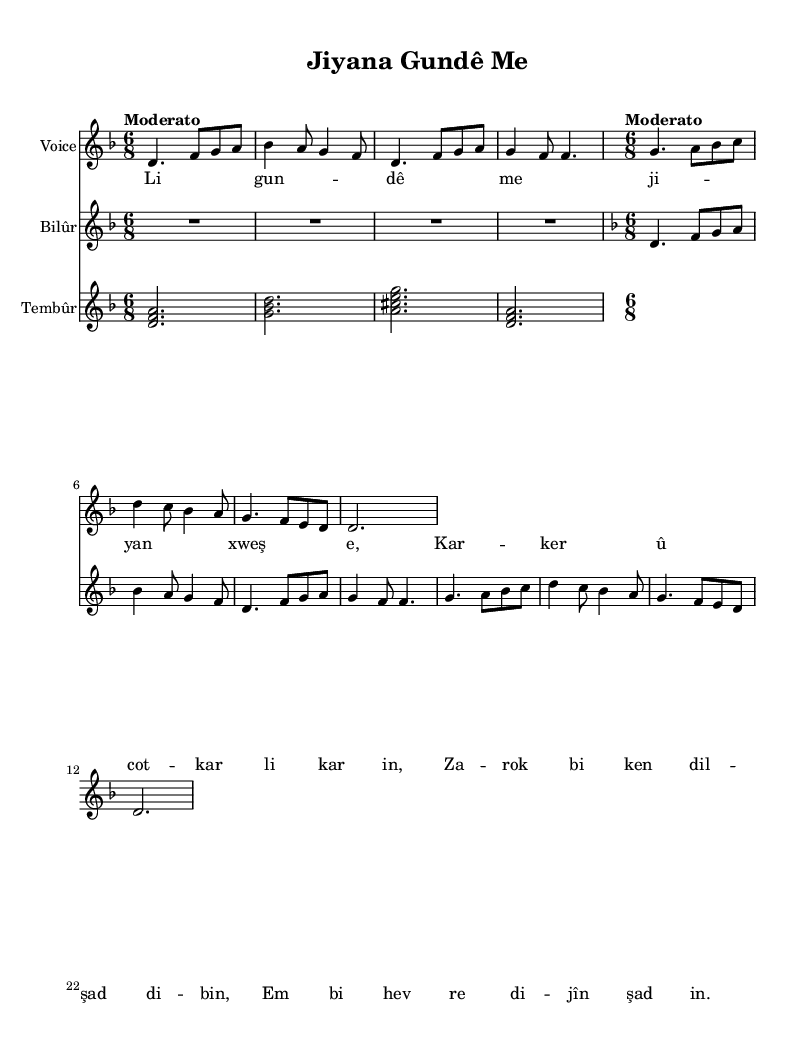What is the key signature of this music? The key signature is indicated at the beginning of the sheet music, and it shows two flats (B and E). Therefore, the key signature corresponds to D minor.
Answer: D minor What is the time signature of this music? The time signature is specified at the beginning of the sheet music as 6/8, which indicates that there are six eighth notes in each measure.
Answer: 6/8 What is the tempo marking in the music? The tempo marking is given at the beginning and describes the speed of the piece, which is labeled as "Moderato," suggesting a moderate pace.
Answer: Moderato How many measures are in the melody section? Counting the measures in the melody, there are eight distinct measures indicated in the score.
Answer: 8 What instrument is indicated to play the chords in the music? The chords are labeled under a staff identified as "Tembûr," which means that this instrument is responsible for playing the harmonic accompaniment.
Answer: Tembûr What theme is explored in the lyrics of the song? Analyzing the lyrics, the theme revolves around village life and communal experiences, with references to working together in the village and living joyfully.
Answer: Village life 